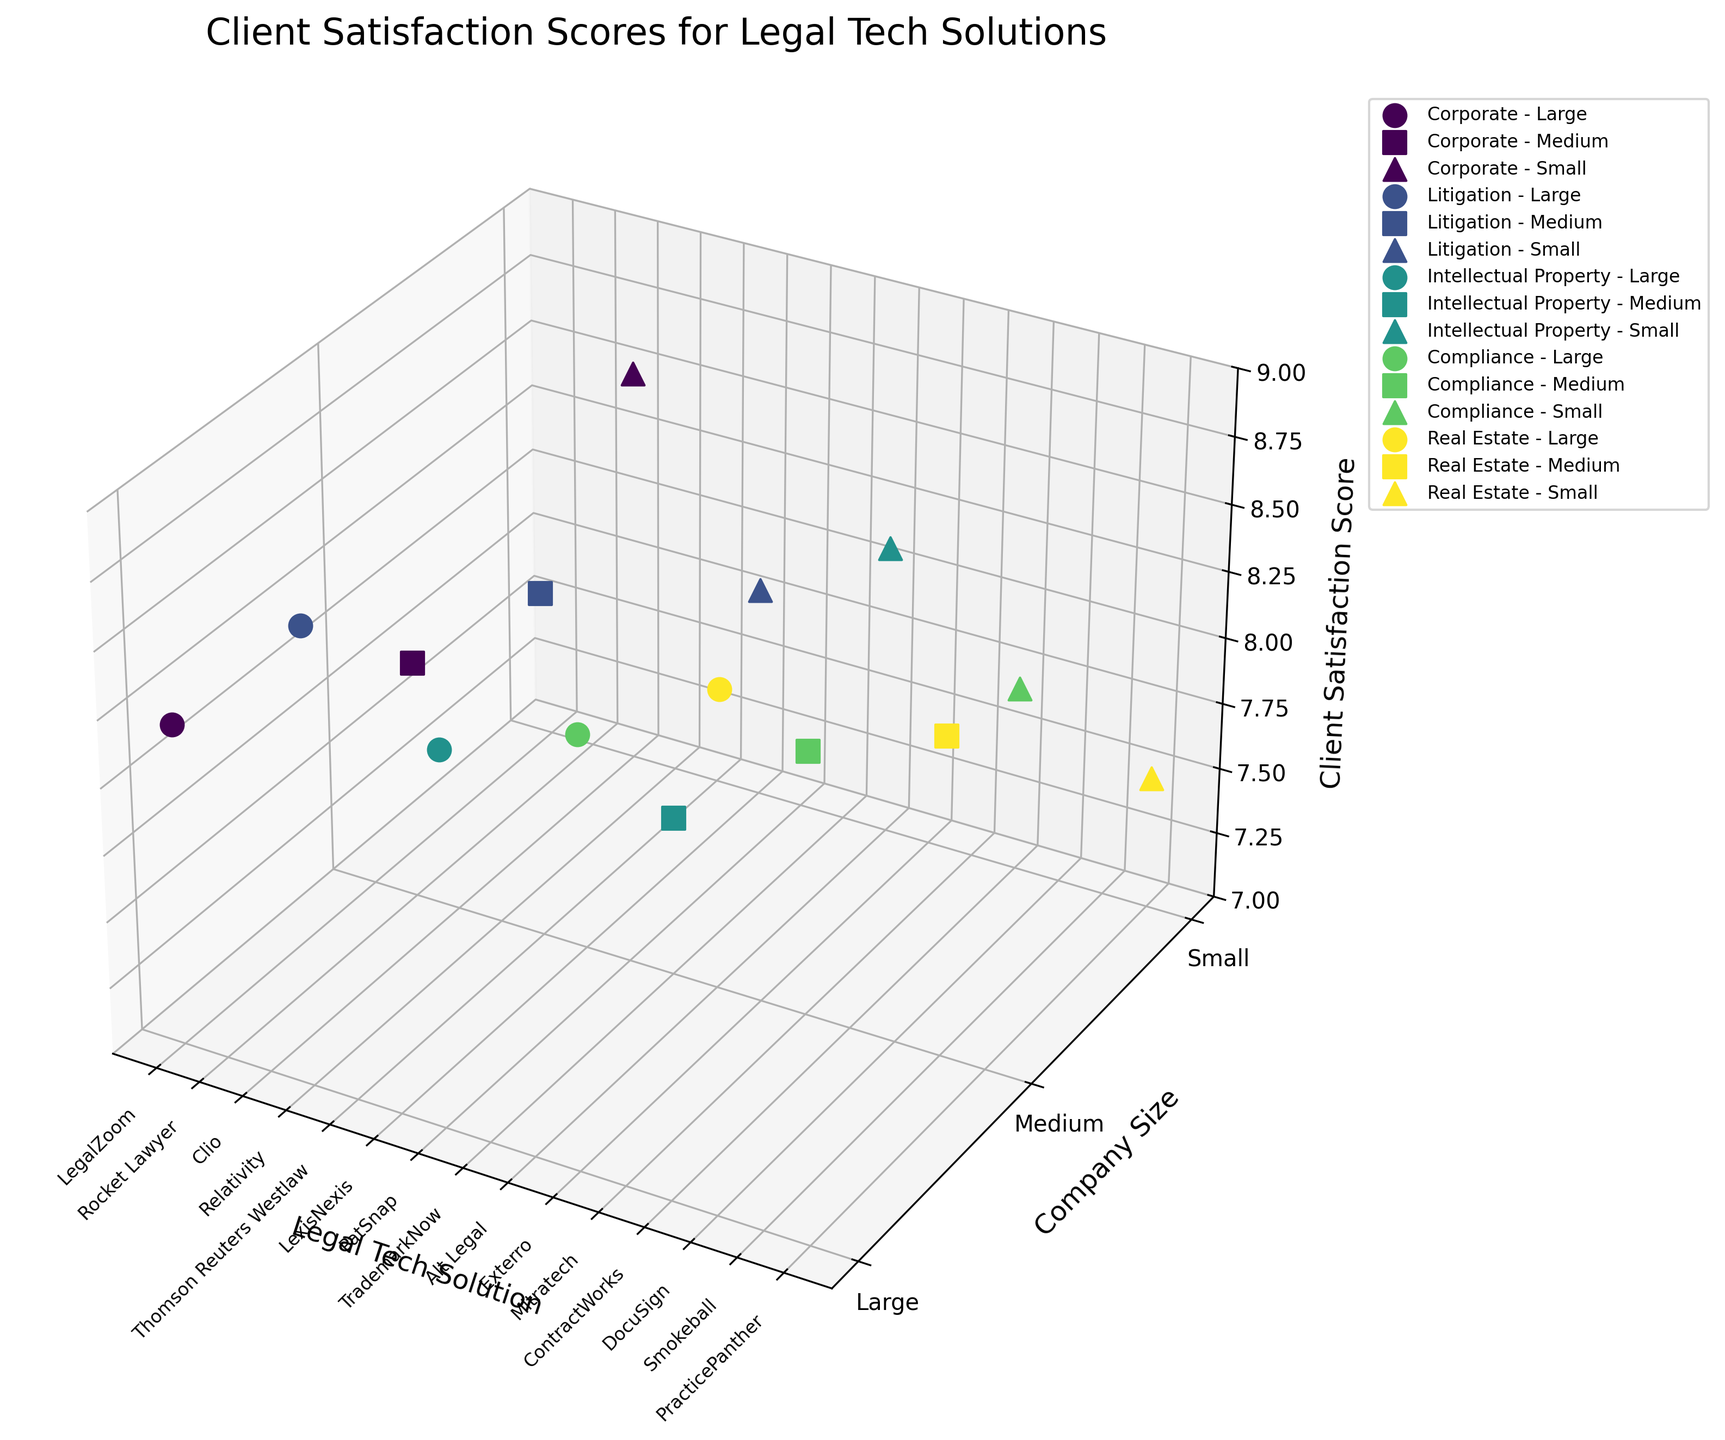How many company sizes are represented in the plot? The plot's y-axis, labeled 'Company Size,' shows distinct markers corresponding to different company sizes. Counting these markers gives the number of represented company sizes.
Answer: 3 What are the highest and lowest client satisfaction scores shown in the plot? The z-axis of the plot, labeled 'Client Satisfaction Score,' indicates the range of scores for each data point. Observing the scatter points, we identify the maximum and minimum z-axis values.
Answer: Highest: 8.9, Lowest: 7.5 Which legal tech solution for small companies in the Corporate sector has the highest client satisfaction score? We locate the Corporate sector data points and filter those with a y-axis value denoting 'Small' companies. Among these, we find the location with the highest z-axis value.
Answer: Clio Which industry sector has the most uniformly high client satisfaction scores? Observing the scatter points categorized by color for each sector and assessing the z-axis values to see which sector's scores are consistently high gives the answer.
Answer: Real Estate Which legal tech solution has the lowest client satisfaction score, and in what industry and company size is it used? Identifying the scatter point with the minimum z-axis value and noting its corresponding data in terms of industry and company size provides the solution.
Answer: PracticePanther, Real Estate, Small How many legal tech solutions have client satisfaction scores greater than 8.3? We count the number of data points whose z-axis values exceed 8.3 by observing the plotted points.
Answer: 6 In terms of client satisfaction, how do small companies fare compared to large companies? We compare the z-axis values of data points marked for 'Small' and 'Large' company sizes to determine if small companies generally have higher or lower satisfaction scores.
Answer: Small companies generally fare worse 